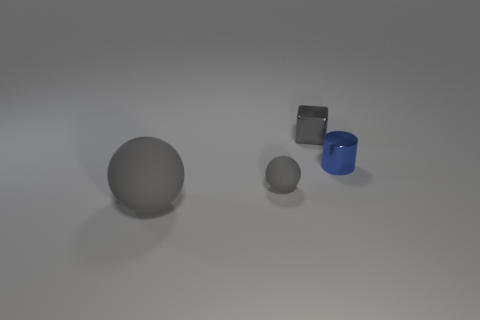What number of gray shiny cubes are to the right of the small thing that is behind the cylinder?
Provide a short and direct response. 0. What number of big gray matte objects are the same shape as the tiny gray matte thing?
Offer a terse response. 1. What number of blue rubber objects are there?
Give a very brief answer. 0. There is a rubber sphere that is on the left side of the small matte ball; what is its color?
Offer a terse response. Gray. The matte sphere to the left of the gray rubber ball behind the big rubber ball is what color?
Keep it short and to the point. Gray. What color is the metallic object that is the same size as the cylinder?
Make the answer very short. Gray. How many objects are both behind the large matte thing and left of the tiny blue metal cylinder?
Give a very brief answer. 2. The rubber object that is the same color as the small rubber sphere is what shape?
Your answer should be very brief. Sphere. What material is the thing that is both in front of the cube and right of the small ball?
Your response must be concise. Metal. Is the number of small matte spheres that are behind the small gray ball less than the number of tiny matte things that are to the right of the small metallic cylinder?
Your answer should be very brief. No. 